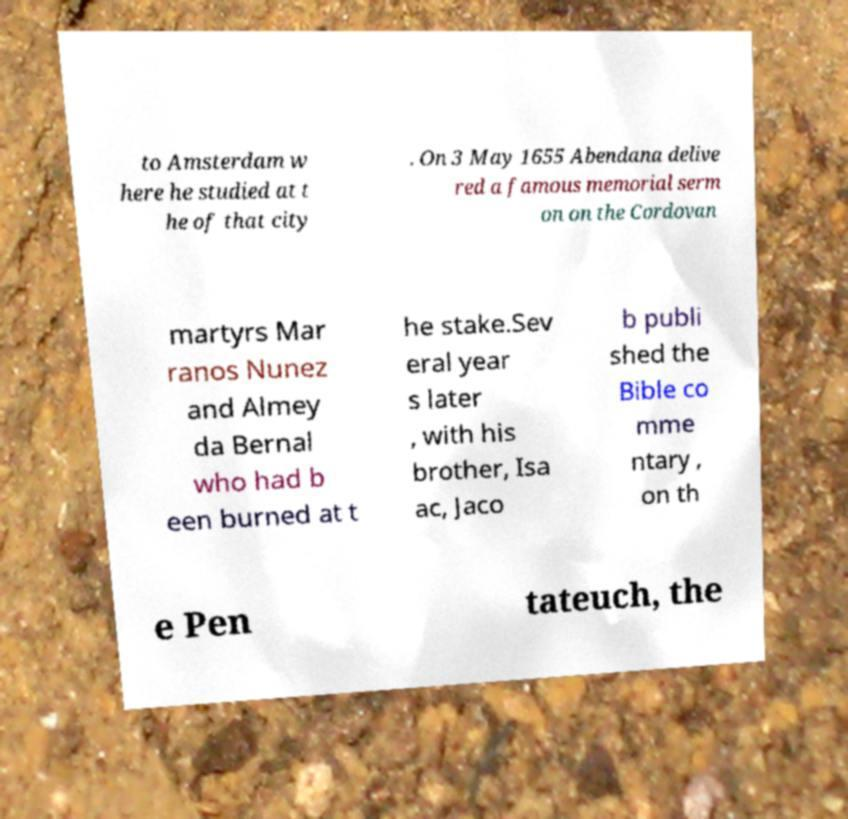Can you read and provide the text displayed in the image?This photo seems to have some interesting text. Can you extract and type it out for me? to Amsterdam w here he studied at t he of that city . On 3 May 1655 Abendana delive red a famous memorial serm on on the Cordovan martyrs Mar ranos Nunez and Almey da Bernal who had b een burned at t he stake.Sev eral year s later , with his brother, Isa ac, Jaco b publi shed the Bible co mme ntary , on th e Pen tateuch, the 